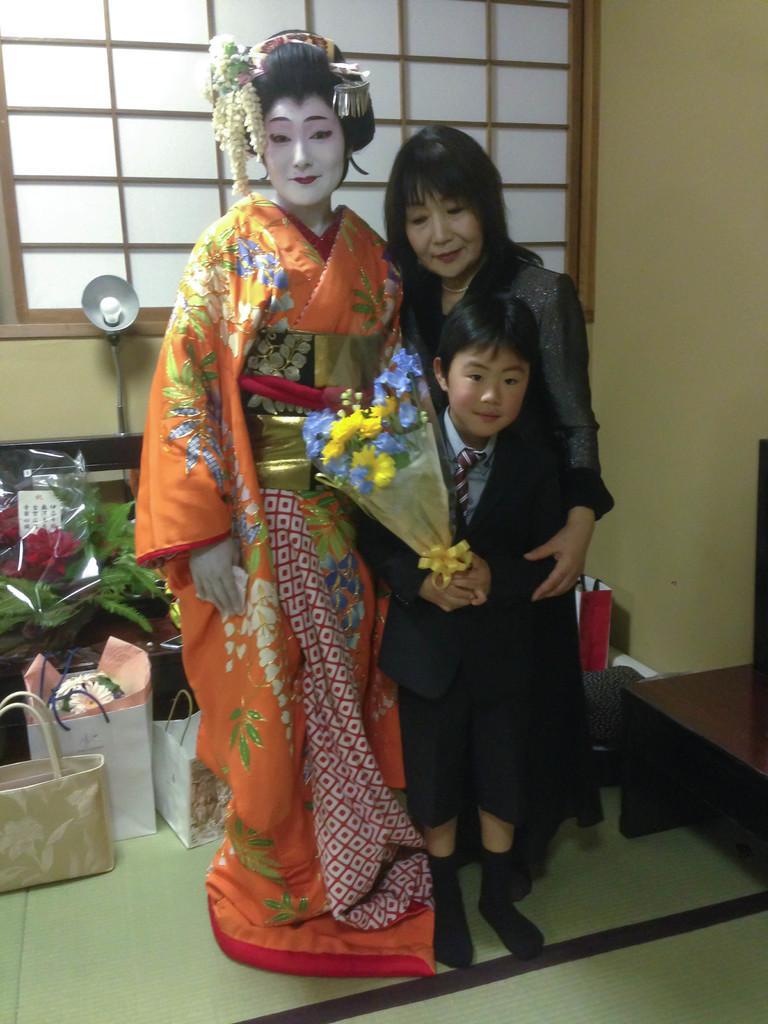Could you give a brief overview of what you see in this image? In this picture we can see three people smiling and standing on the floor, flower bouquet, bags, table, leaves, lamp, window, wall and some objects and a woman wore a costume. 